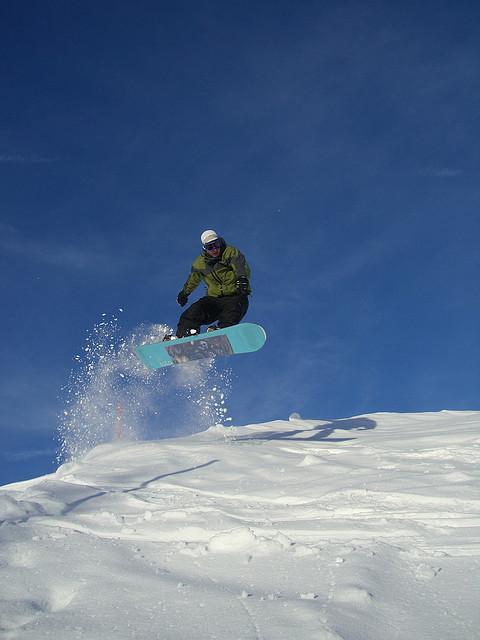How many people can you see?
Give a very brief answer. 1. How many cars are to the right?
Give a very brief answer. 0. 